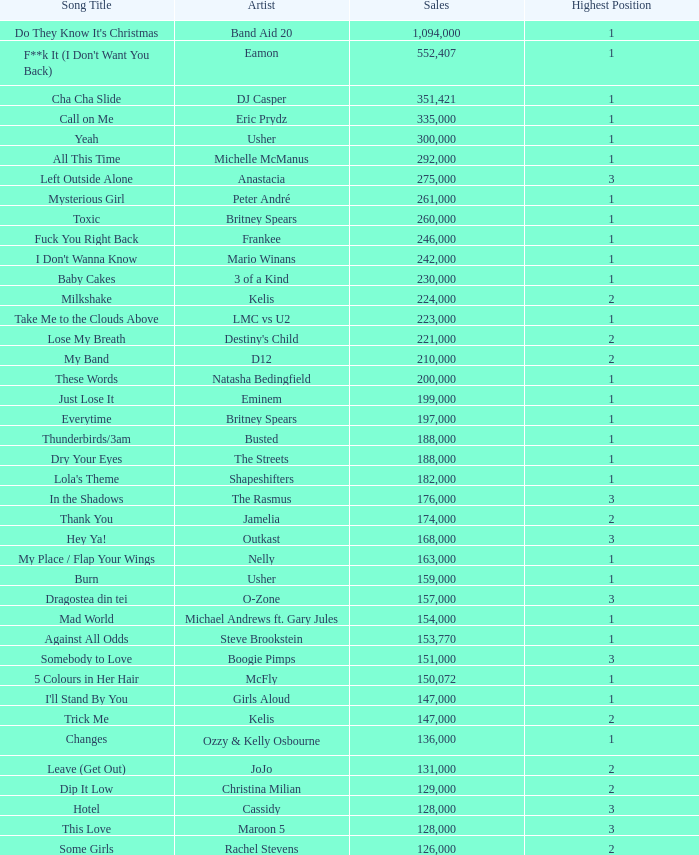What were the sales for Dj Casper when he was in a position lower than 13? 351421.0. 